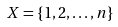<formula> <loc_0><loc_0><loc_500><loc_500>X = \{ 1 , 2 , \dots , n \}</formula> 